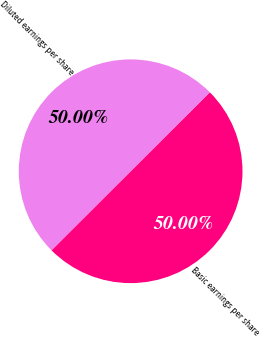Convert chart. <chart><loc_0><loc_0><loc_500><loc_500><pie_chart><fcel>Basic earnings per share<fcel>Diluted earnings per share<nl><fcel>50.0%<fcel>50.0%<nl></chart> 